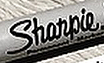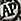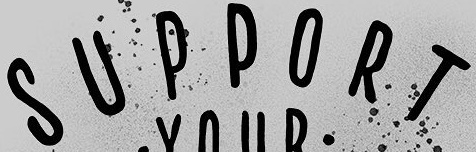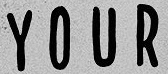What words are shown in these images in order, separated by a semicolon? Shanpie; AP; SUPPORT; YOUR 